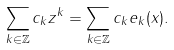<formula> <loc_0><loc_0><loc_500><loc_500>\sum _ { k \in \mathbb { Z } } c _ { k } z ^ { k } = \sum _ { k \in \mathbb { Z } } c _ { k } e _ { k } ( x ) .</formula> 